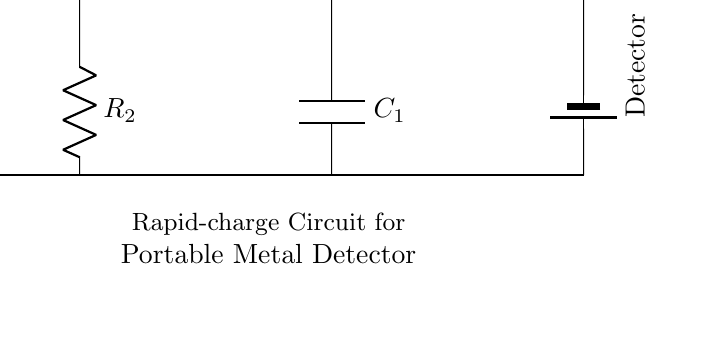What is the input voltage of this circuit? The input voltage is labeled as V_in, indicating the voltage supplied to the circuit.
Answer: V_in What component is used to limit current in this circuit? Resistor R_1 is used for limiting current, as resistors are designed to resist the flow of electric current.
Answer: R_1 How many energy storage components are there in the circuit? There are two energy storage components: a capacitor (C_1) and an inductor (L_1). Both components store energy in different ways.
Answer: 2 What is the function of the second battery labeled in the diagram? The second battery, labeled as Detector, supplies power to the portable metal detector, ensuring it has the necessary voltage to function.
Answer: Detector What is the total voltage across the battery and the resistor? The total voltage across the battery and the resistor is determined by V_in minus the voltage drop across R_1, which is not specified in the circuit details.
Answer: V_in - V_R1 (not specified) What type of circuit is this primarily classified as? This circuit is classified as a charging circuit, as it is designed to recharge the portable metal detector's battery quickly.
Answer: Charging circuit What role does the capacitor play in this circuit? The capacitor (C_1) helps to smooth out voltage fluctuations and stores charge, providing a stable voltage for the detector during operation.
Answer: Smoothing voltage 